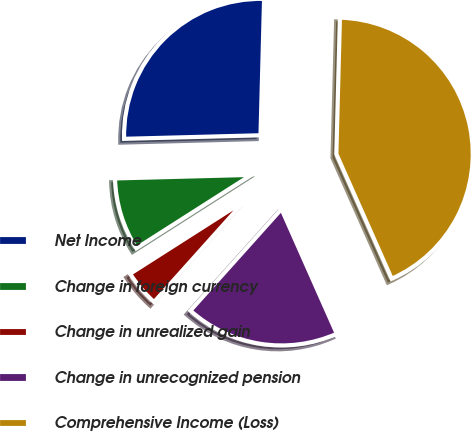Convert chart. <chart><loc_0><loc_0><loc_500><loc_500><pie_chart><fcel>Net Income<fcel>Change in foreign currency<fcel>Change in unrealized gain<fcel>Change in unrecognized pension<fcel>Comprehensive Income (Loss)<nl><fcel>25.83%<fcel>8.62%<fcel>4.33%<fcel>18.28%<fcel>42.93%<nl></chart> 